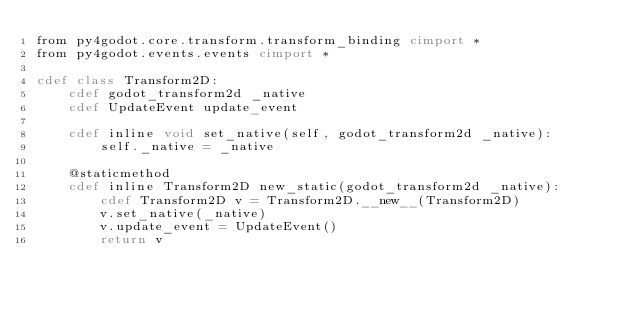Convert code to text. <code><loc_0><loc_0><loc_500><loc_500><_Cython_>from py4godot.core.transform.transform_binding cimport *
from py4godot.events.events cimport *

cdef class Transform2D:
    cdef godot_transform2d _native
    cdef UpdateEvent update_event

    cdef inline void set_native(self, godot_transform2d _native):
        self._native = _native

    @staticmethod
    cdef inline Transform2D new_static(godot_transform2d _native):
        cdef Transform2D v = Transform2D.__new__(Transform2D)
        v.set_native(_native)
        v.update_event = UpdateEvent()
        return v</code> 